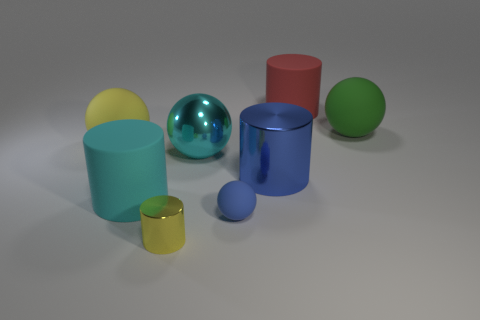What material is the tiny ball that is the same color as the big metal cylinder?
Offer a very short reply. Rubber. The cyan shiny thing that is the same size as the green ball is what shape?
Your answer should be compact. Sphere. Is there a small thing that has the same shape as the big red rubber object?
Provide a succinct answer. Yes. There is a cyan matte thing behind the small object that is on the right side of the big cyan metallic sphere; what shape is it?
Provide a short and direct response. Cylinder. What is the shape of the green rubber thing?
Give a very brief answer. Sphere. There is a big cylinder behind the big sphere that is behind the rubber ball that is to the left of the tiny cylinder; what is its material?
Make the answer very short. Rubber. How many other things are made of the same material as the small yellow thing?
Provide a succinct answer. 2. How many big cyan things are left of the large cyan thing right of the cyan cylinder?
Your answer should be very brief. 1. What number of balls are either big yellow matte things or large red metallic objects?
Make the answer very short. 1. There is a big cylinder that is both to the right of the small metallic cylinder and in front of the green ball; what color is it?
Make the answer very short. Blue. 